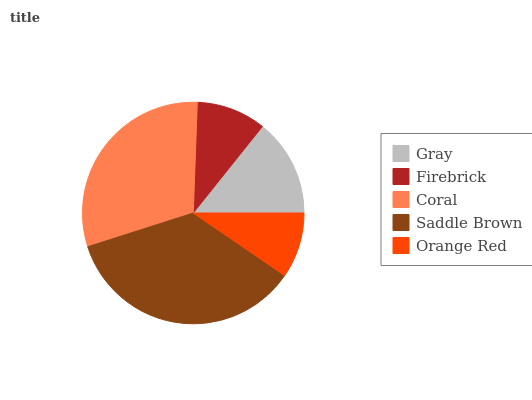Is Orange Red the minimum?
Answer yes or no. Yes. Is Saddle Brown the maximum?
Answer yes or no. Yes. Is Firebrick the minimum?
Answer yes or no. No. Is Firebrick the maximum?
Answer yes or no. No. Is Gray greater than Firebrick?
Answer yes or no. Yes. Is Firebrick less than Gray?
Answer yes or no. Yes. Is Firebrick greater than Gray?
Answer yes or no. No. Is Gray less than Firebrick?
Answer yes or no. No. Is Gray the high median?
Answer yes or no. Yes. Is Gray the low median?
Answer yes or no. Yes. Is Coral the high median?
Answer yes or no. No. Is Saddle Brown the low median?
Answer yes or no. No. 